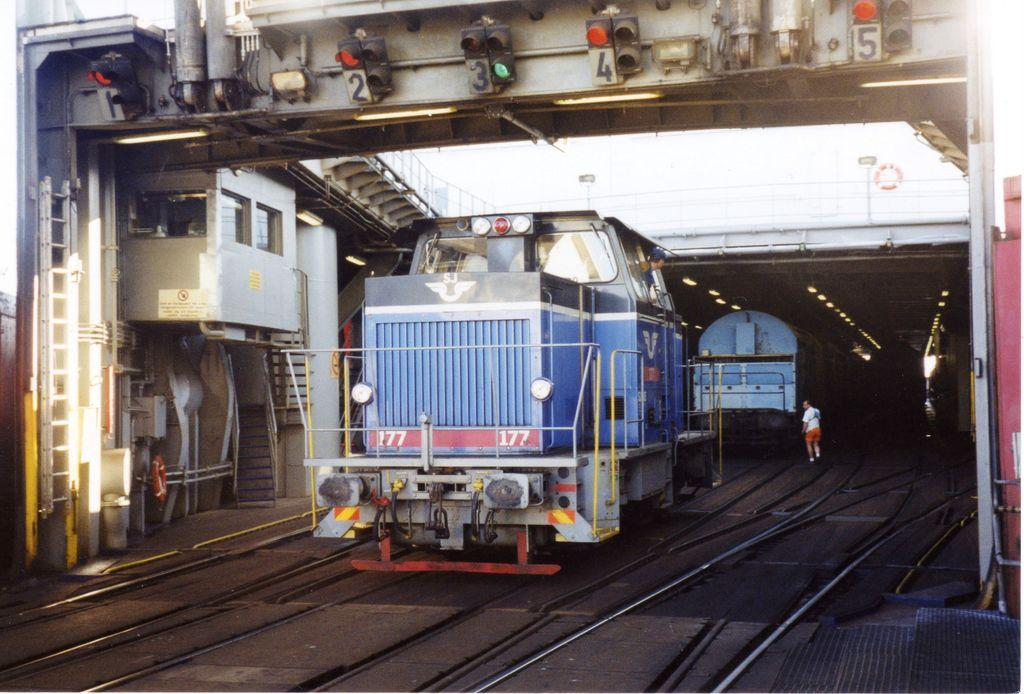What can be seen running across the image? There are railway tracks in the image. Who or what is on the railway tracks? There is a person and a train on the railway tracks. What is located on the left side of the image? There is a building on the left side of the image. What structure is present in the image that allows the railway tracks to pass over an obstacle? There is a bridge in the image. What is on the bridge? There is a traffic light and numbers on the bridge. What type of attraction can be seen in the image? There is no attraction present in the image; it features railway tracks, a person, a train, a building, a bridge, a traffic light, and numbers. Can you see someone kicking a ball in the image? There is no ball or kicking activity present in the image. 